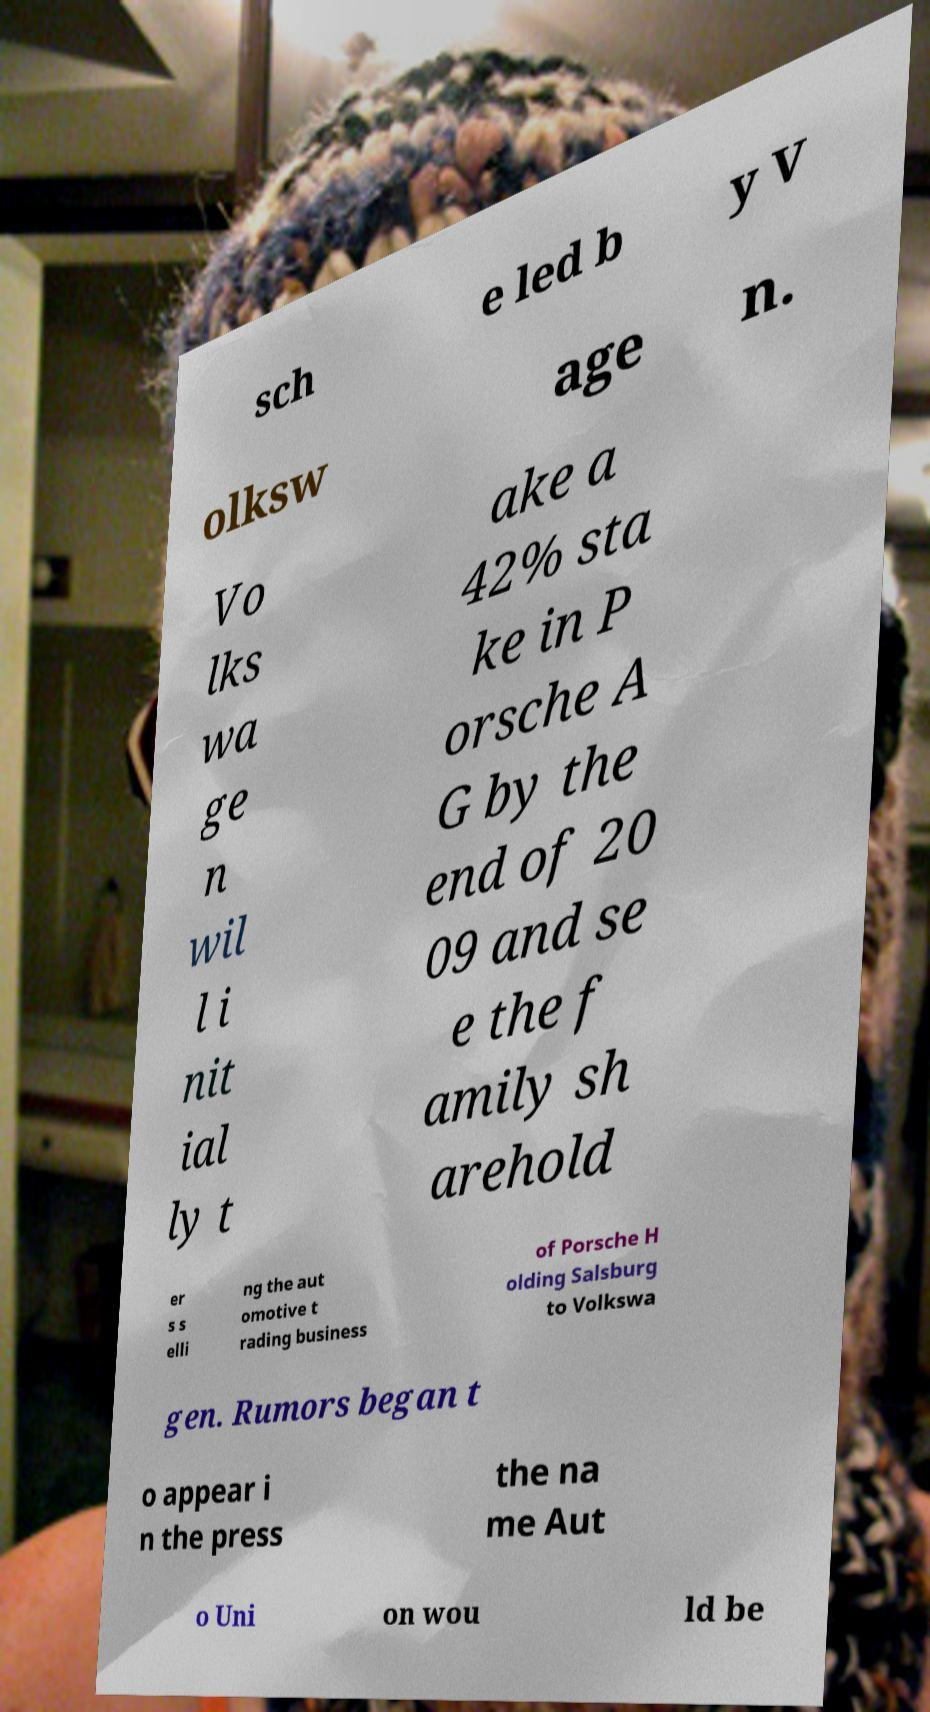Could you extract and type out the text from this image? sch e led b y V olksw age n. Vo lks wa ge n wil l i nit ial ly t ake a 42% sta ke in P orsche A G by the end of 20 09 and se e the f amily sh arehold er s s elli ng the aut omotive t rading business of Porsche H olding Salsburg to Volkswa gen. Rumors began t o appear i n the press the na me Aut o Uni on wou ld be 